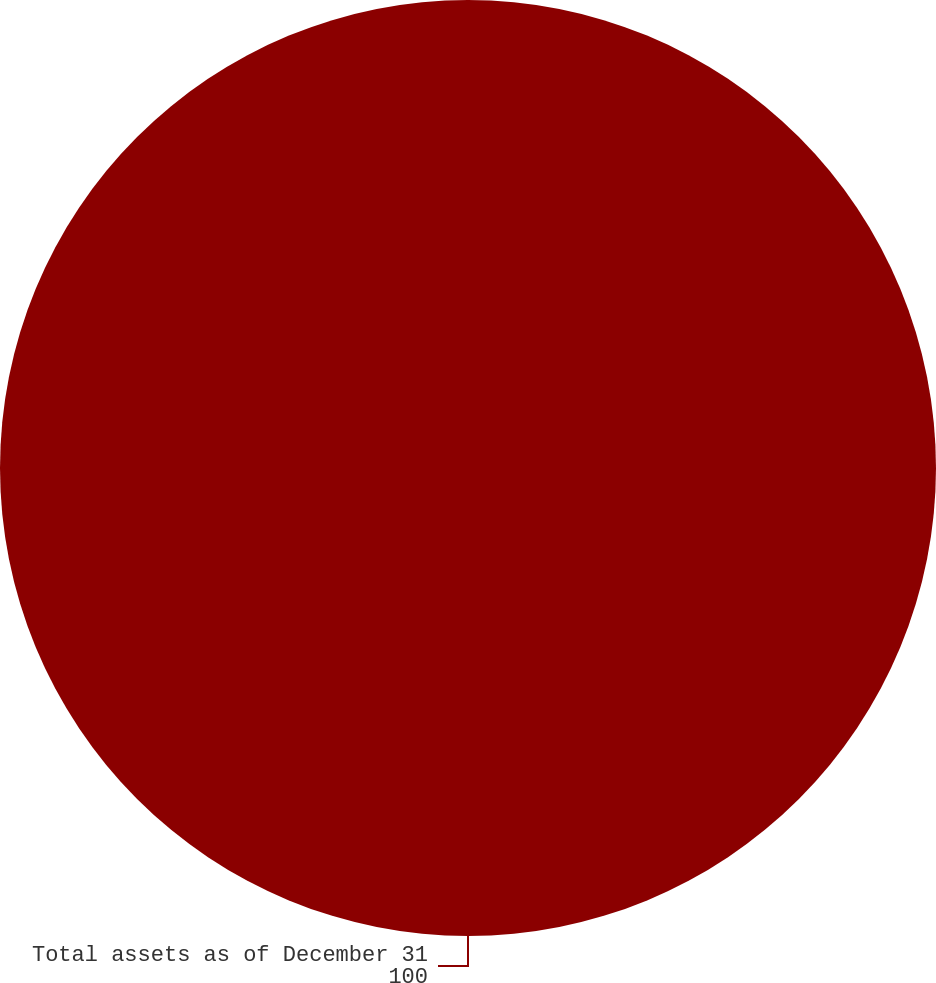Convert chart. <chart><loc_0><loc_0><loc_500><loc_500><pie_chart><fcel>Total assets as of December 31<nl><fcel>100.0%<nl></chart> 